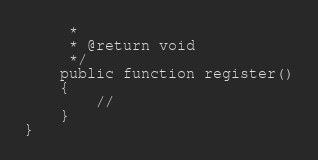Convert code to text. <code><loc_0><loc_0><loc_500><loc_500><_PHP_>     *
     * @return void
     */
    public function register()
    {
        //
    }
}
</code> 